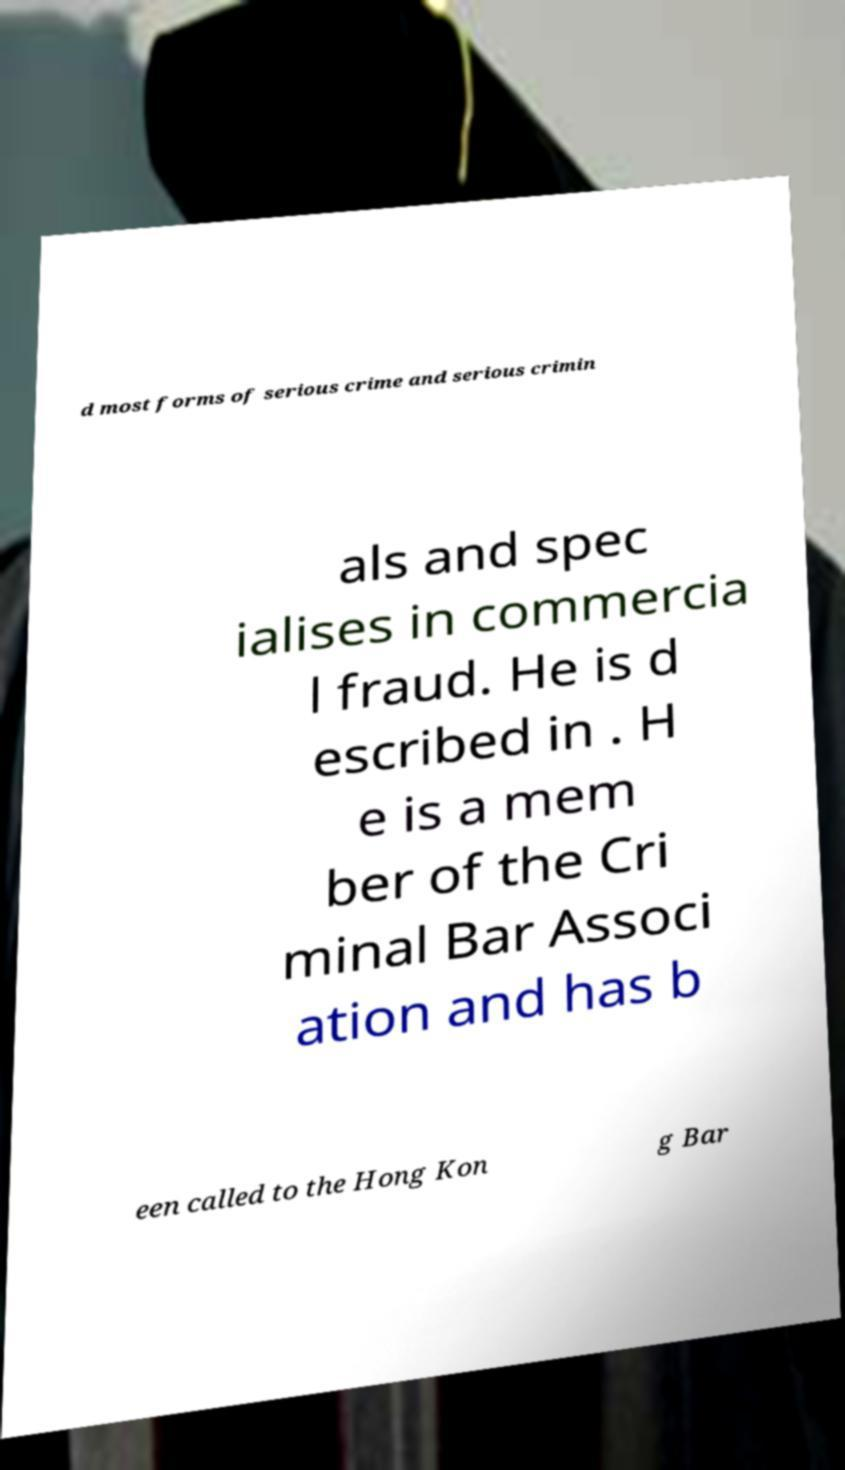For documentation purposes, I need the text within this image transcribed. Could you provide that? d most forms of serious crime and serious crimin als and spec ialises in commercia l fraud. He is d escribed in . H e is a mem ber of the Cri minal Bar Associ ation and has b een called to the Hong Kon g Bar 